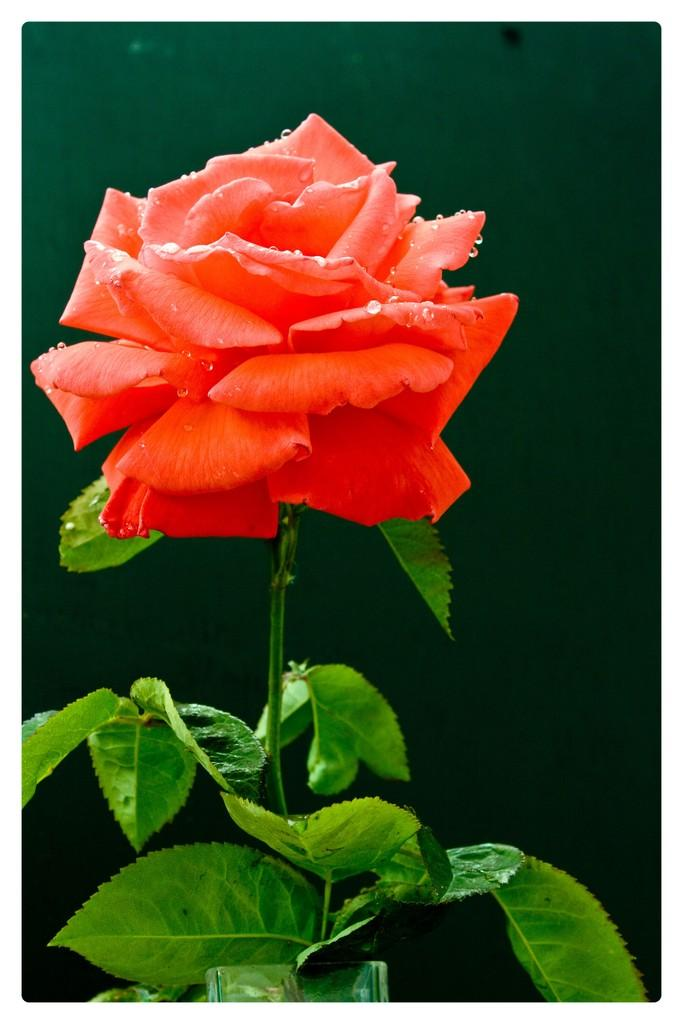What type of plant is in the image? There is a plant in the image, but the specific type cannot be determined from the facts provided. What color are the leaves of the plant? The leaves of the plant are green. What color is the flower on the plant? The flower on the plant is orange. What color is the background of the image? The background of the image is green. How many bells are hanging from the plant in the image? There are no bells present in the image; it only features a plant with green leaves and an orange flower. 